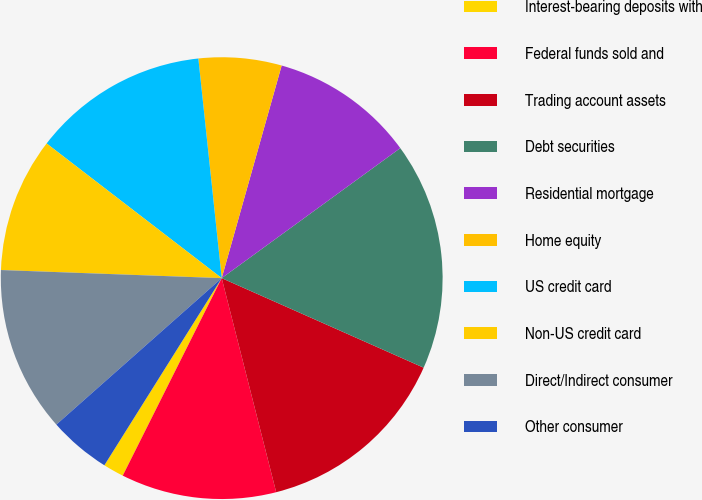<chart> <loc_0><loc_0><loc_500><loc_500><pie_chart><fcel>Interest-bearing deposits with<fcel>Federal funds sold and<fcel>Trading account assets<fcel>Debt securities<fcel>Residential mortgage<fcel>Home equity<fcel>US credit card<fcel>Non-US credit card<fcel>Direct/Indirect consumer<fcel>Other consumer<nl><fcel>1.52%<fcel>11.36%<fcel>14.39%<fcel>16.66%<fcel>10.61%<fcel>6.06%<fcel>12.88%<fcel>9.85%<fcel>12.12%<fcel>4.55%<nl></chart> 